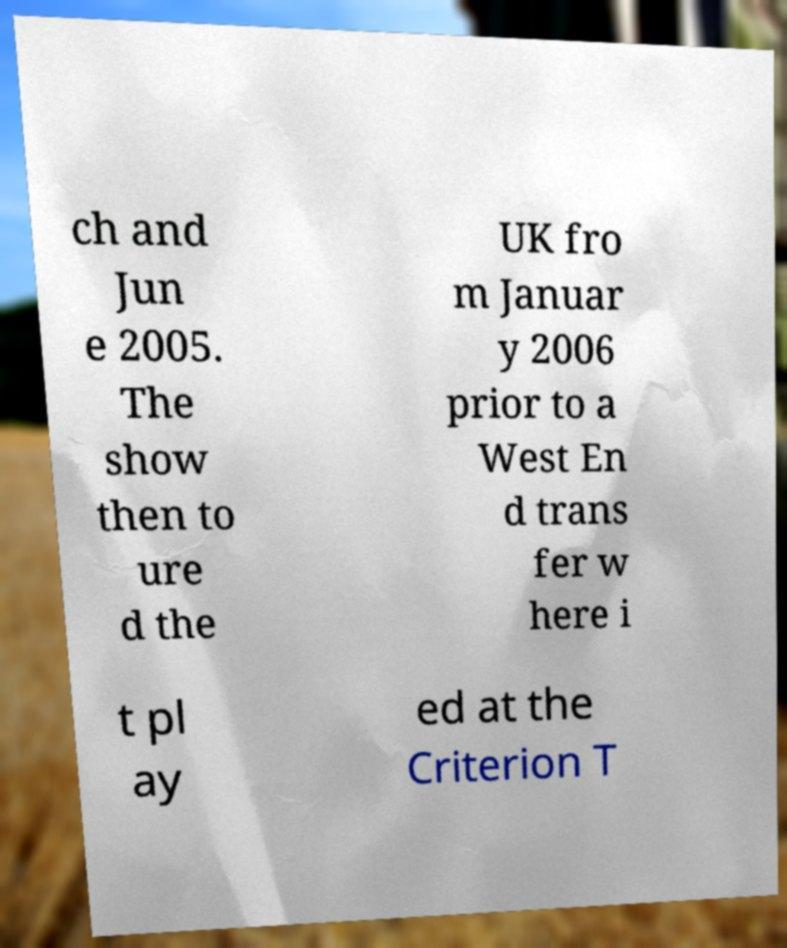There's text embedded in this image that I need extracted. Can you transcribe it verbatim? ch and Jun e 2005. The show then to ure d the UK fro m Januar y 2006 prior to a West En d trans fer w here i t pl ay ed at the Criterion T 